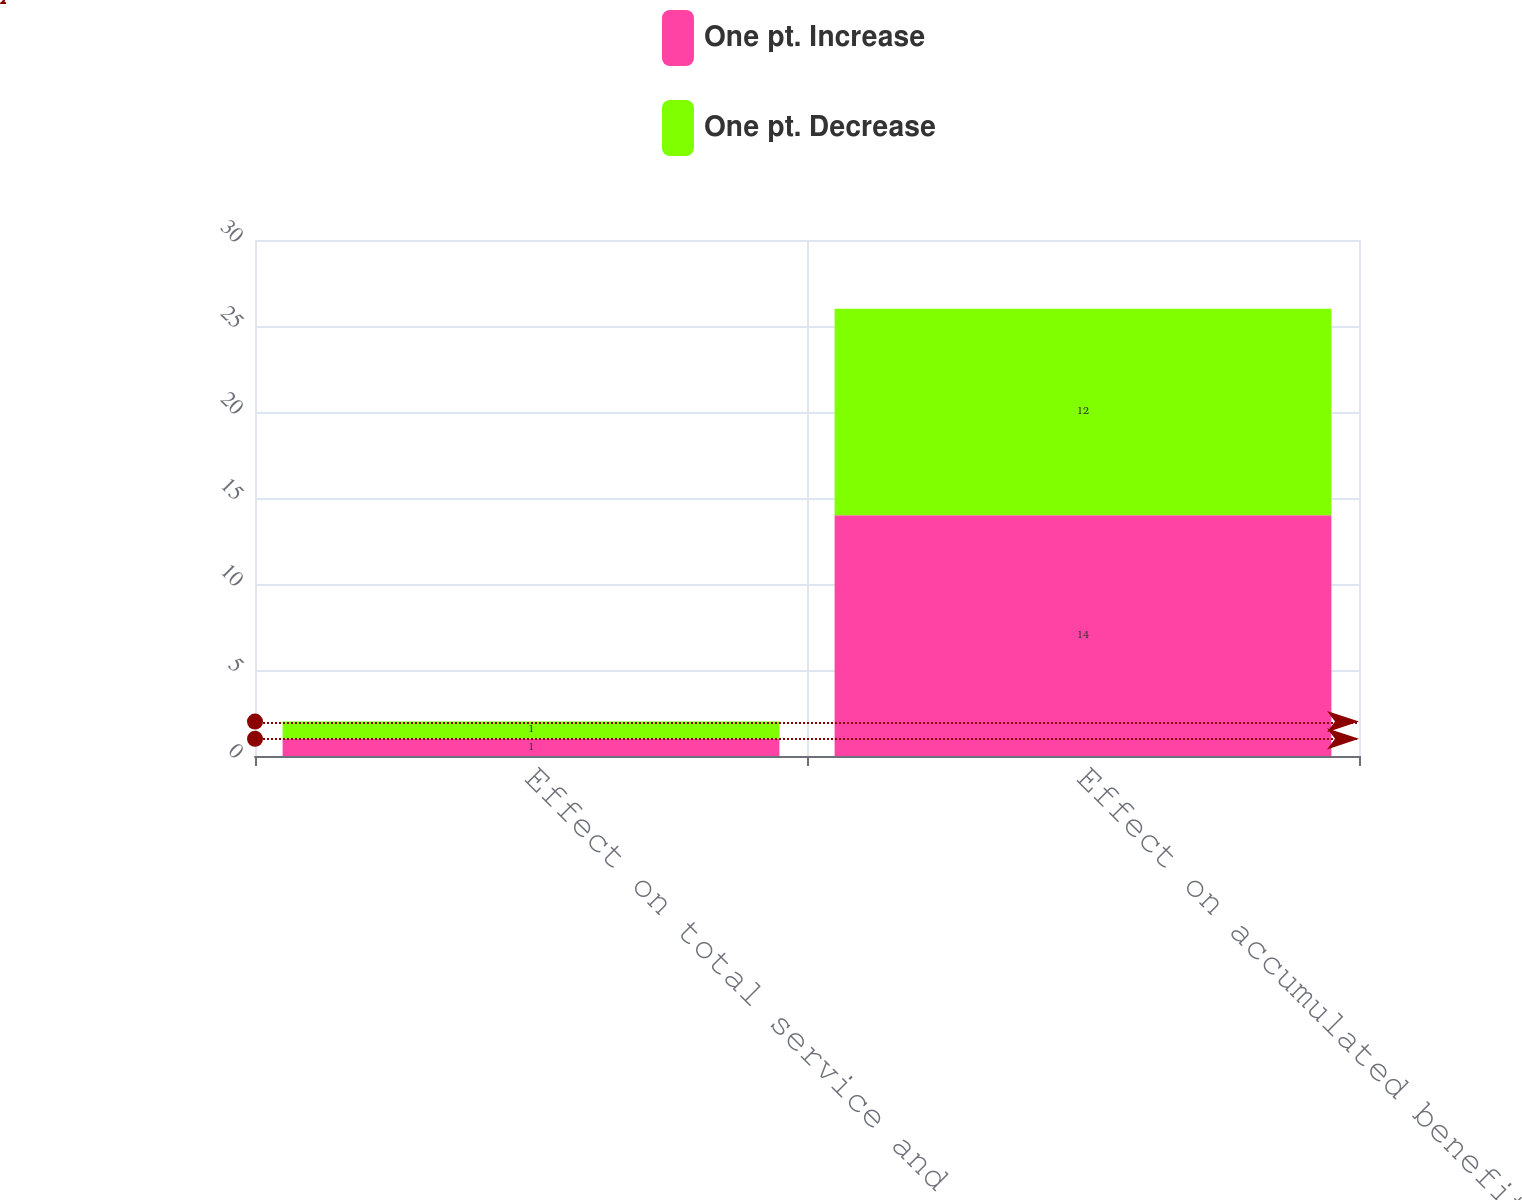<chart> <loc_0><loc_0><loc_500><loc_500><stacked_bar_chart><ecel><fcel>Effect on total service and<fcel>Effect on accumulated benefit<nl><fcel>One pt. Increase<fcel>1<fcel>14<nl><fcel>One pt. Decrease<fcel>1<fcel>12<nl></chart> 